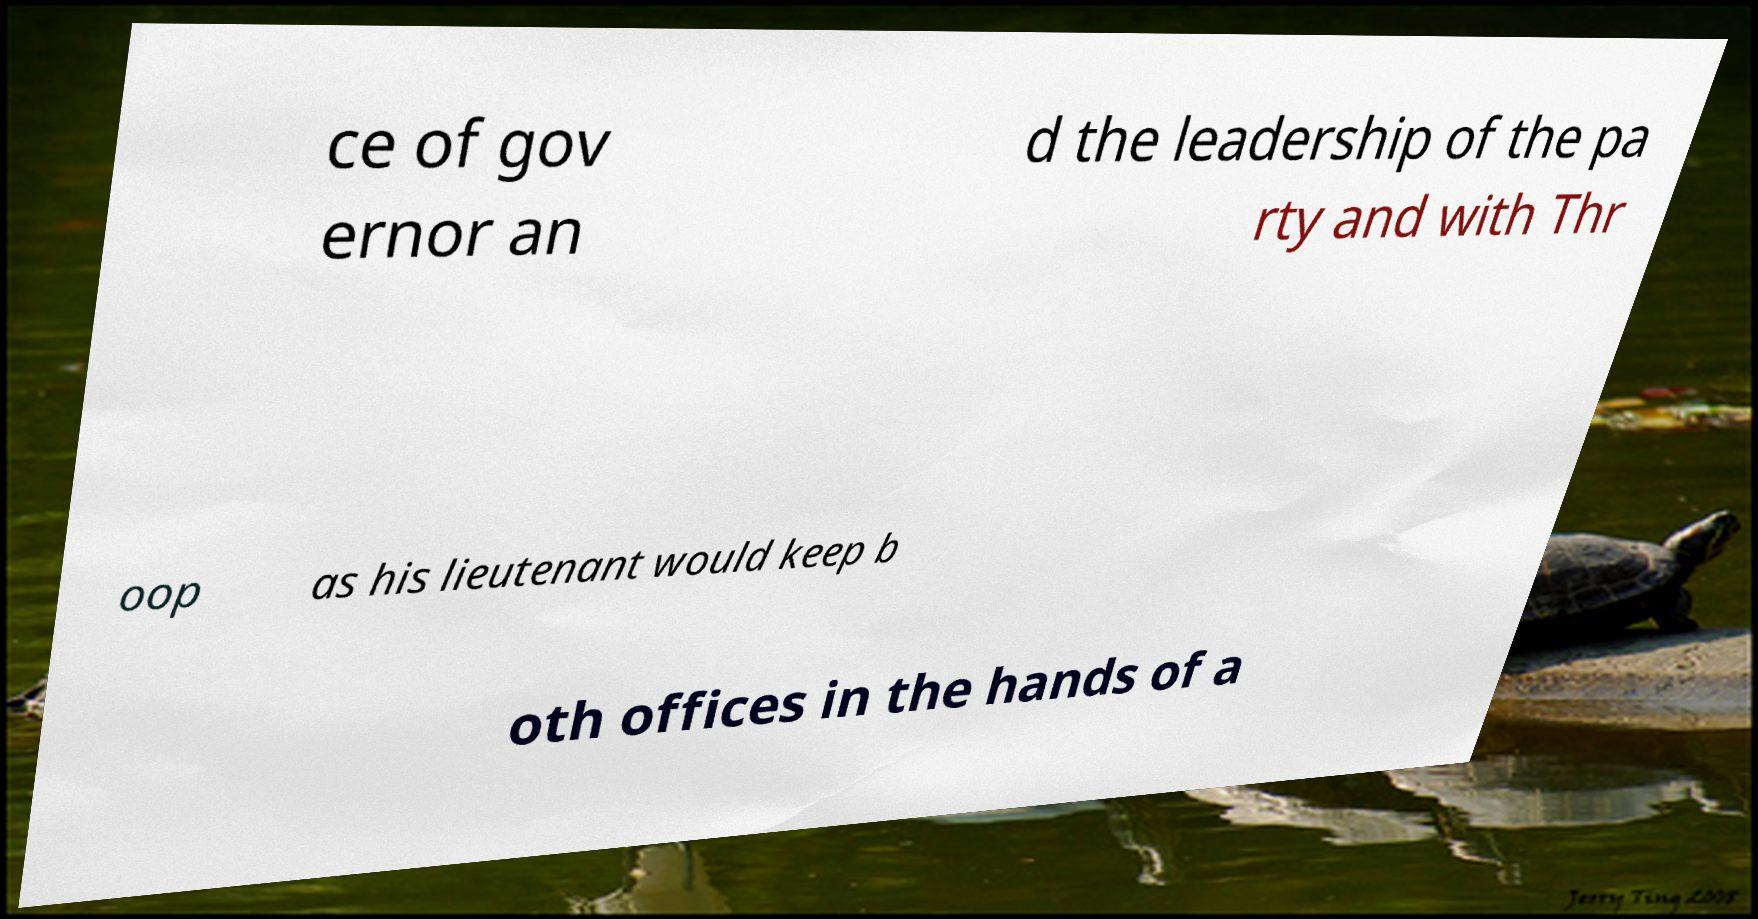What messages or text are displayed in this image? I need them in a readable, typed format. ce of gov ernor an d the leadership of the pa rty and with Thr oop as his lieutenant would keep b oth offices in the hands of a 